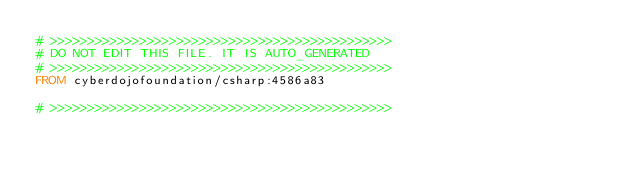<code> <loc_0><loc_0><loc_500><loc_500><_Dockerfile_># >>>>>>>>>>>>>>>>>>>>>>>>>>>>>>>>>>>>>>>>>>>>>>
# DO NOT EDIT THIS FILE. IT IS AUTO_GENERATED
# >>>>>>>>>>>>>>>>>>>>>>>>>>>>>>>>>>>>>>>>>>>>>>
FROM cyberdojofoundation/csharp:4586a83

# >>>>>>>>>>>>>>>>>>>>>>>>>>>>>>>>>>>>>>>>>>>>>></code> 